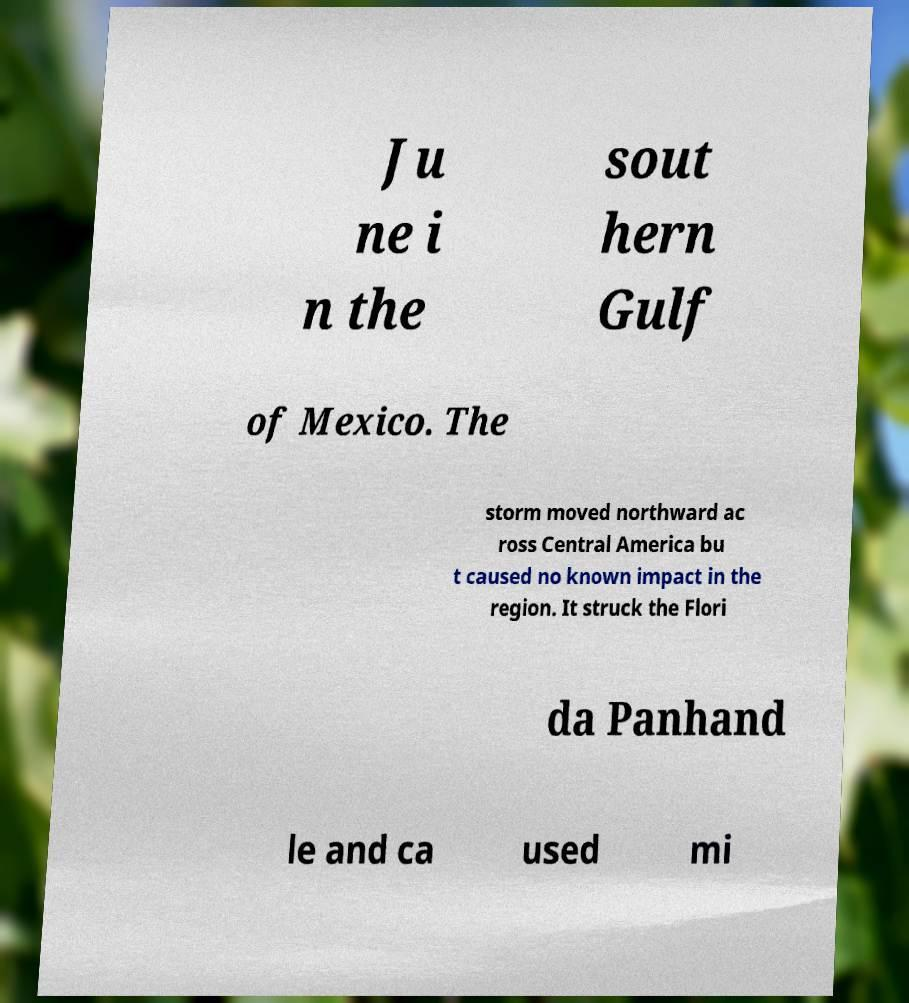I need the written content from this picture converted into text. Can you do that? Ju ne i n the sout hern Gulf of Mexico. The storm moved northward ac ross Central America bu t caused no known impact in the region. It struck the Flori da Panhand le and ca used mi 